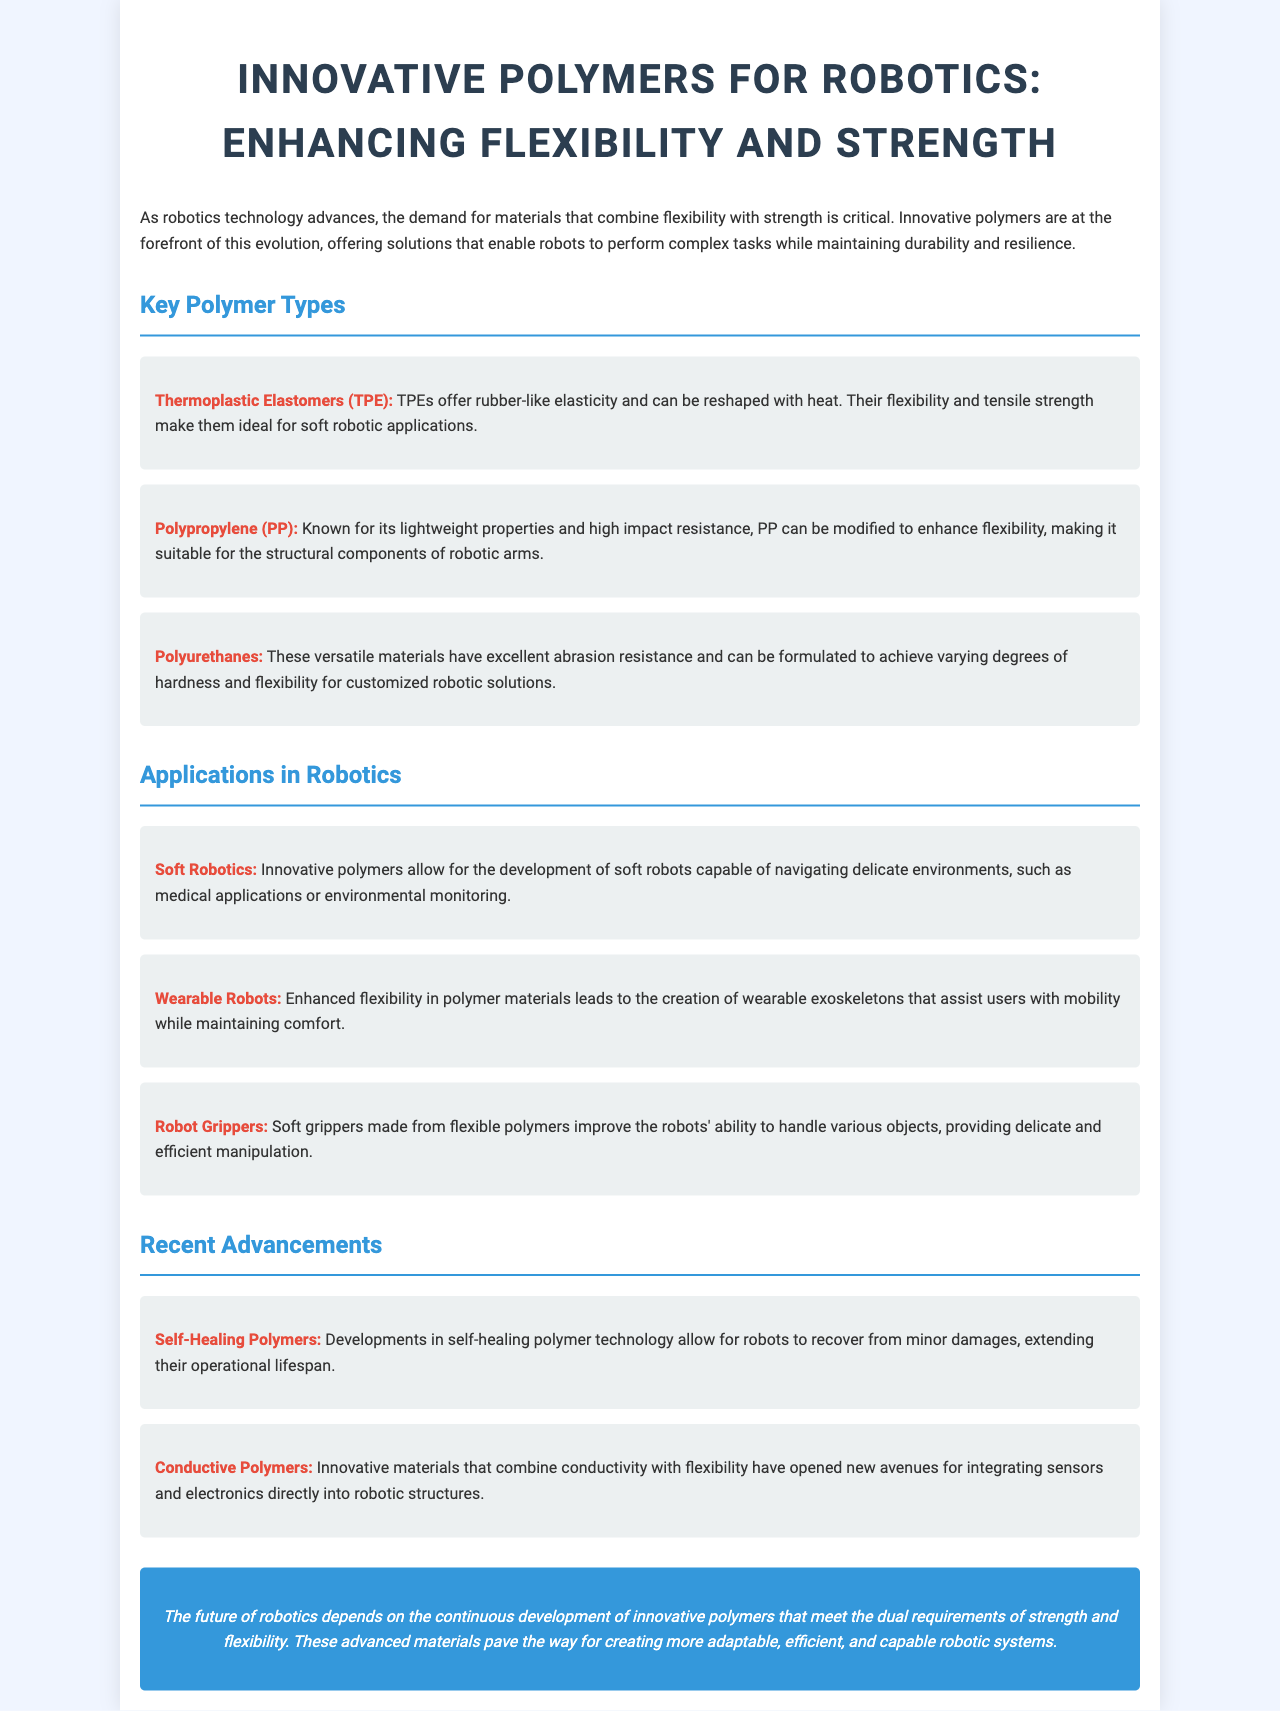What are thermoplastic elastomers known for? Thermoplastic elastomers are known for offering rubber-like elasticity and can be reshaped with heat.
Answer: Rubber-like elasticity What is the main advantage of polypropylene? Polypropylene is known for its lightweight properties and high impact resistance.
Answer: Lightweight properties What application allows robots to navigate delicate environments? Soft robotics allows robots to navigate delicate environments, such as medical applications or environmental monitoring.
Answer: Soft robotics What recent advancement allows robots to recover from minor damages? Self-healing polymers allow robots to recover from minor damages.
Answer: Self-healing polymers How do conductive polymers benefit robotics? Conductive polymers open new avenues for integrating sensors and electronics directly into robotic structures.
Answer: Integrating sensors and electronics 